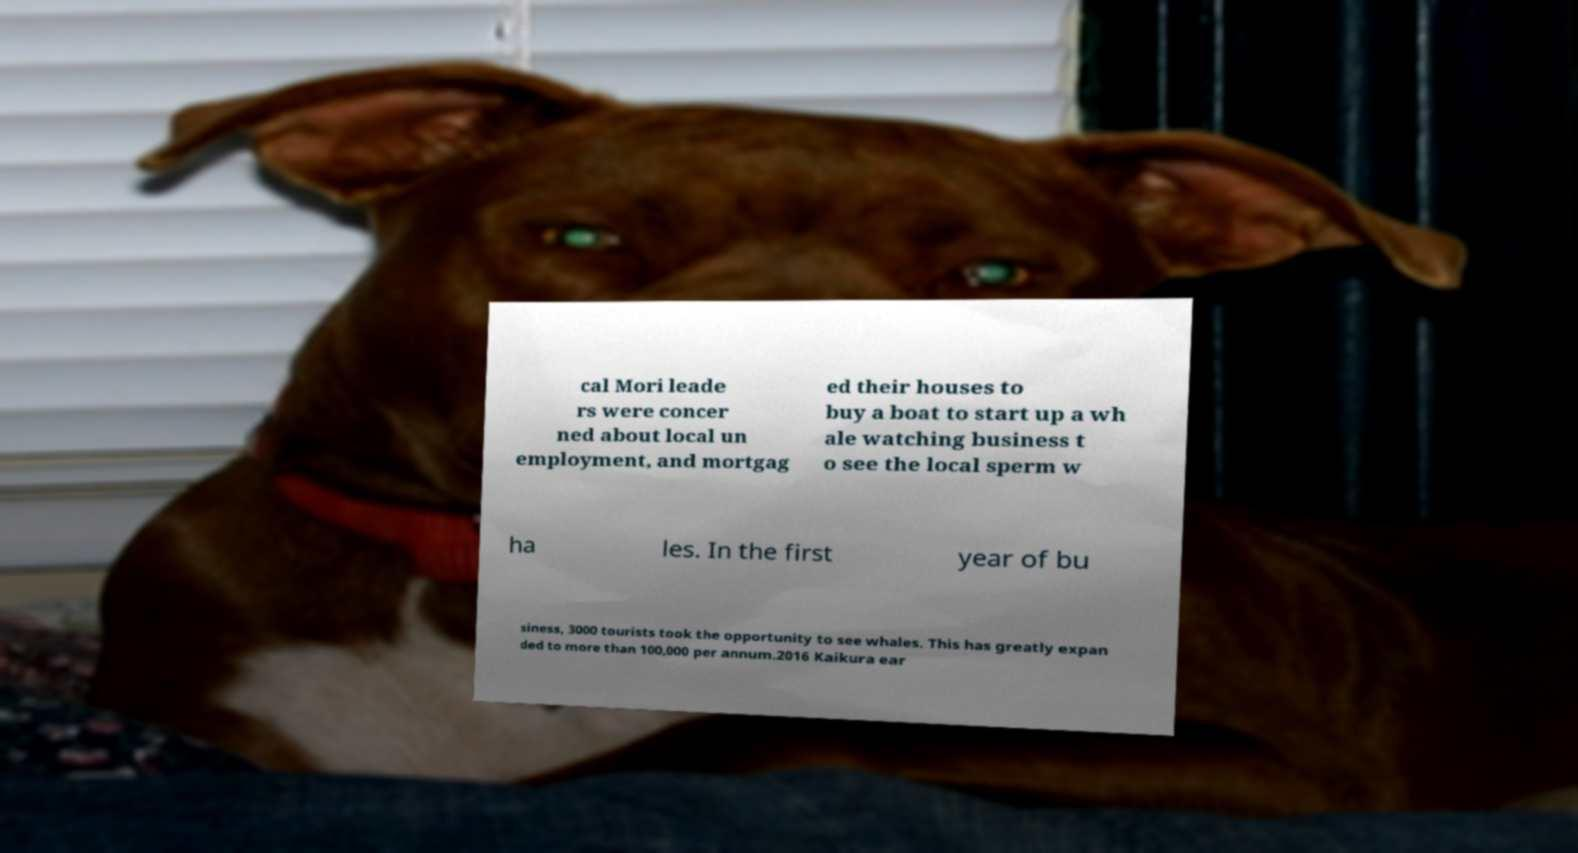Please identify and transcribe the text found in this image. cal Mori leade rs were concer ned about local un employment, and mortgag ed their houses to buy a boat to start up a wh ale watching business t o see the local sperm w ha les. In the first year of bu siness, 3000 tourists took the opportunity to see whales. This has greatly expan ded to more than 100,000 per annum.2016 Kaikura ear 